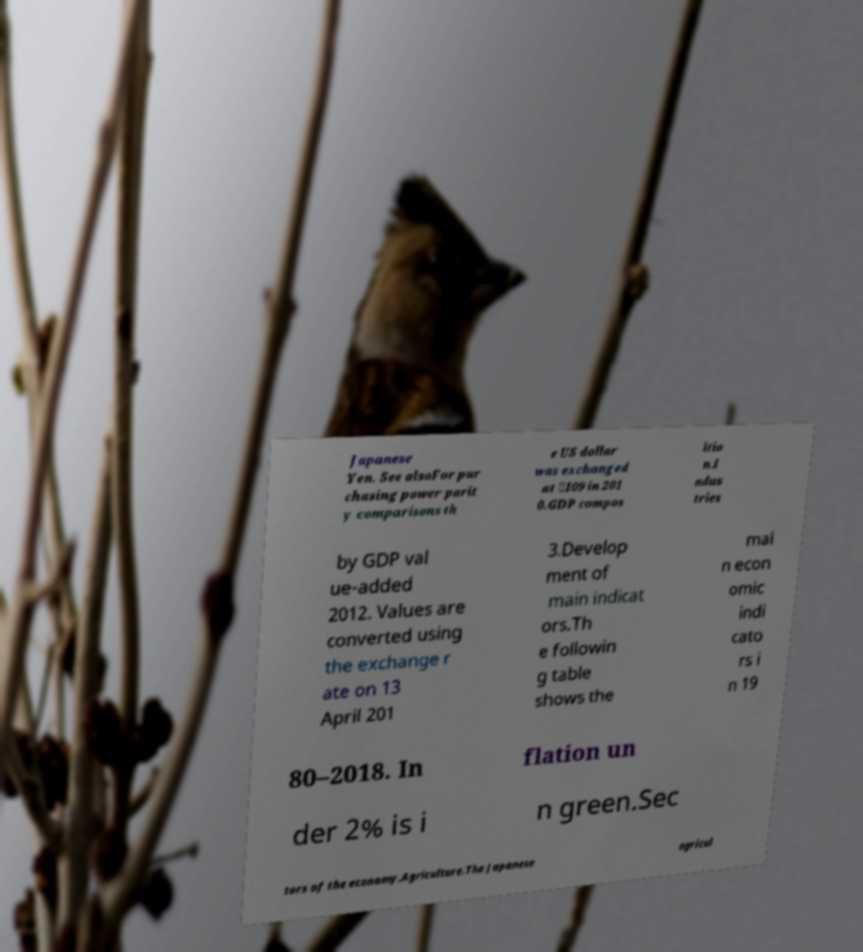Can you accurately transcribe the text from the provided image for me? Japanese Yen. See alsoFor pur chasing power parit y comparisons th e US dollar was exchanged at ￥109 in 201 0.GDP compos itio n.I ndus tries by GDP val ue-added 2012. Values are converted using the exchange r ate on 13 April 201 3.Develop ment of main indicat ors.Th e followin g table shows the mai n econ omic indi cato rs i n 19 80–2018. In flation un der 2% is i n green.Sec tors of the economy.Agriculture.The Japanese agricul 